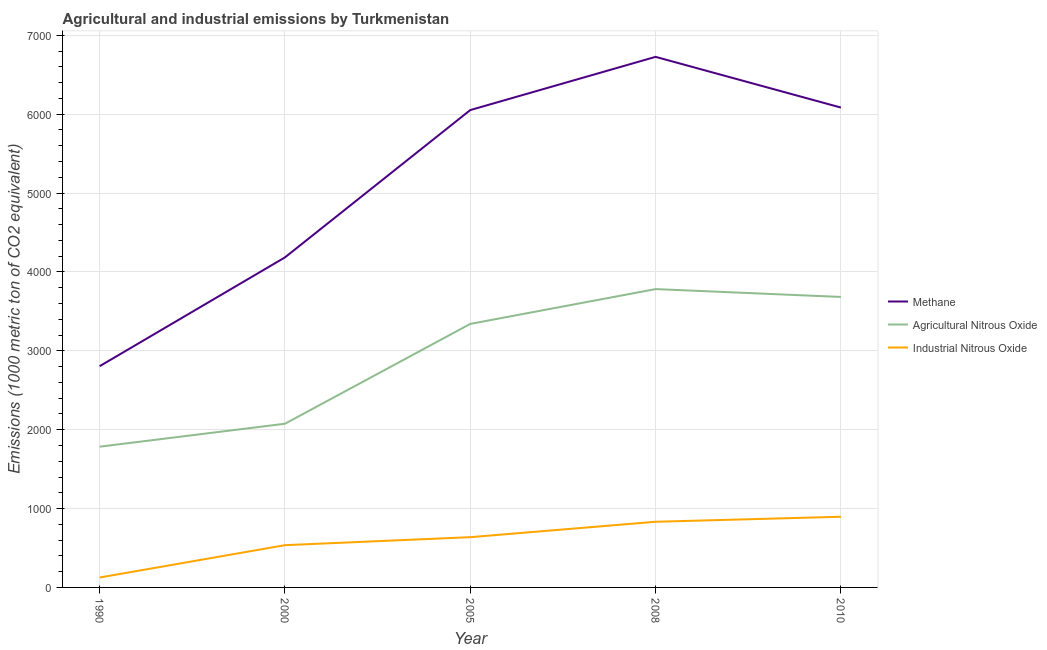How many different coloured lines are there?
Your response must be concise. 3. Does the line corresponding to amount of agricultural nitrous oxide emissions intersect with the line corresponding to amount of methane emissions?
Keep it short and to the point. No. Is the number of lines equal to the number of legend labels?
Your answer should be very brief. Yes. What is the amount of agricultural nitrous oxide emissions in 2000?
Offer a terse response. 2075.3. Across all years, what is the maximum amount of methane emissions?
Offer a terse response. 6726.9. Across all years, what is the minimum amount of industrial nitrous oxide emissions?
Provide a succinct answer. 125.6. What is the total amount of agricultural nitrous oxide emissions in the graph?
Provide a succinct answer. 1.47e+04. What is the difference between the amount of industrial nitrous oxide emissions in 2005 and that in 2008?
Make the answer very short. -195.3. What is the difference between the amount of industrial nitrous oxide emissions in 2008 and the amount of agricultural nitrous oxide emissions in 2000?
Provide a succinct answer. -1242.8. What is the average amount of methane emissions per year?
Offer a very short reply. 5170.44. In the year 2005, what is the difference between the amount of agricultural nitrous oxide emissions and amount of industrial nitrous oxide emissions?
Offer a very short reply. 2704.1. What is the ratio of the amount of methane emissions in 2005 to that in 2008?
Ensure brevity in your answer.  0.9. Is the amount of agricultural nitrous oxide emissions in 2000 less than that in 2010?
Provide a succinct answer. Yes. Is the difference between the amount of methane emissions in 2000 and 2008 greater than the difference between the amount of industrial nitrous oxide emissions in 2000 and 2008?
Offer a very short reply. No. What is the difference between the highest and the second highest amount of agricultural nitrous oxide emissions?
Keep it short and to the point. 99.5. What is the difference between the highest and the lowest amount of industrial nitrous oxide emissions?
Your answer should be very brief. 770.5. In how many years, is the amount of industrial nitrous oxide emissions greater than the average amount of industrial nitrous oxide emissions taken over all years?
Provide a short and direct response. 3. Is the sum of the amount of methane emissions in 2008 and 2010 greater than the maximum amount of industrial nitrous oxide emissions across all years?
Provide a succinct answer. Yes. Is it the case that in every year, the sum of the amount of methane emissions and amount of agricultural nitrous oxide emissions is greater than the amount of industrial nitrous oxide emissions?
Your answer should be very brief. Yes. Is the amount of agricultural nitrous oxide emissions strictly greater than the amount of methane emissions over the years?
Provide a short and direct response. No. How many lines are there?
Your answer should be compact. 3. How many years are there in the graph?
Offer a terse response. 5. What is the difference between two consecutive major ticks on the Y-axis?
Your answer should be compact. 1000. Where does the legend appear in the graph?
Provide a succinct answer. Center right. How many legend labels are there?
Make the answer very short. 3. How are the legend labels stacked?
Your response must be concise. Vertical. What is the title of the graph?
Provide a succinct answer. Agricultural and industrial emissions by Turkmenistan. Does "Food" appear as one of the legend labels in the graph?
Offer a terse response. No. What is the label or title of the Y-axis?
Your response must be concise. Emissions (1000 metric ton of CO2 equivalent). What is the Emissions (1000 metric ton of CO2 equivalent) of Methane in 1990?
Keep it short and to the point. 2804.7. What is the Emissions (1000 metric ton of CO2 equivalent) in Agricultural Nitrous Oxide in 1990?
Keep it short and to the point. 1784.5. What is the Emissions (1000 metric ton of CO2 equivalent) in Industrial Nitrous Oxide in 1990?
Your answer should be very brief. 125.6. What is the Emissions (1000 metric ton of CO2 equivalent) in Methane in 2000?
Offer a very short reply. 4184.3. What is the Emissions (1000 metric ton of CO2 equivalent) in Agricultural Nitrous Oxide in 2000?
Your answer should be very brief. 2075.3. What is the Emissions (1000 metric ton of CO2 equivalent) in Industrial Nitrous Oxide in 2000?
Provide a short and direct response. 535.7. What is the Emissions (1000 metric ton of CO2 equivalent) of Methane in 2005?
Your response must be concise. 6052.3. What is the Emissions (1000 metric ton of CO2 equivalent) in Agricultural Nitrous Oxide in 2005?
Offer a terse response. 3341.3. What is the Emissions (1000 metric ton of CO2 equivalent) of Industrial Nitrous Oxide in 2005?
Ensure brevity in your answer.  637.2. What is the Emissions (1000 metric ton of CO2 equivalent) of Methane in 2008?
Ensure brevity in your answer.  6726.9. What is the Emissions (1000 metric ton of CO2 equivalent) in Agricultural Nitrous Oxide in 2008?
Offer a very short reply. 3782.4. What is the Emissions (1000 metric ton of CO2 equivalent) of Industrial Nitrous Oxide in 2008?
Keep it short and to the point. 832.5. What is the Emissions (1000 metric ton of CO2 equivalent) in Methane in 2010?
Give a very brief answer. 6084. What is the Emissions (1000 metric ton of CO2 equivalent) of Agricultural Nitrous Oxide in 2010?
Offer a terse response. 3682.9. What is the Emissions (1000 metric ton of CO2 equivalent) of Industrial Nitrous Oxide in 2010?
Your answer should be very brief. 896.1. Across all years, what is the maximum Emissions (1000 metric ton of CO2 equivalent) in Methane?
Make the answer very short. 6726.9. Across all years, what is the maximum Emissions (1000 metric ton of CO2 equivalent) of Agricultural Nitrous Oxide?
Provide a short and direct response. 3782.4. Across all years, what is the maximum Emissions (1000 metric ton of CO2 equivalent) of Industrial Nitrous Oxide?
Offer a very short reply. 896.1. Across all years, what is the minimum Emissions (1000 metric ton of CO2 equivalent) in Methane?
Ensure brevity in your answer.  2804.7. Across all years, what is the minimum Emissions (1000 metric ton of CO2 equivalent) in Agricultural Nitrous Oxide?
Make the answer very short. 1784.5. Across all years, what is the minimum Emissions (1000 metric ton of CO2 equivalent) in Industrial Nitrous Oxide?
Your answer should be very brief. 125.6. What is the total Emissions (1000 metric ton of CO2 equivalent) of Methane in the graph?
Keep it short and to the point. 2.59e+04. What is the total Emissions (1000 metric ton of CO2 equivalent) of Agricultural Nitrous Oxide in the graph?
Offer a terse response. 1.47e+04. What is the total Emissions (1000 metric ton of CO2 equivalent) in Industrial Nitrous Oxide in the graph?
Your answer should be compact. 3027.1. What is the difference between the Emissions (1000 metric ton of CO2 equivalent) in Methane in 1990 and that in 2000?
Make the answer very short. -1379.6. What is the difference between the Emissions (1000 metric ton of CO2 equivalent) of Agricultural Nitrous Oxide in 1990 and that in 2000?
Your answer should be compact. -290.8. What is the difference between the Emissions (1000 metric ton of CO2 equivalent) in Industrial Nitrous Oxide in 1990 and that in 2000?
Give a very brief answer. -410.1. What is the difference between the Emissions (1000 metric ton of CO2 equivalent) in Methane in 1990 and that in 2005?
Make the answer very short. -3247.6. What is the difference between the Emissions (1000 metric ton of CO2 equivalent) in Agricultural Nitrous Oxide in 1990 and that in 2005?
Your response must be concise. -1556.8. What is the difference between the Emissions (1000 metric ton of CO2 equivalent) in Industrial Nitrous Oxide in 1990 and that in 2005?
Your response must be concise. -511.6. What is the difference between the Emissions (1000 metric ton of CO2 equivalent) of Methane in 1990 and that in 2008?
Provide a short and direct response. -3922.2. What is the difference between the Emissions (1000 metric ton of CO2 equivalent) of Agricultural Nitrous Oxide in 1990 and that in 2008?
Your answer should be very brief. -1997.9. What is the difference between the Emissions (1000 metric ton of CO2 equivalent) of Industrial Nitrous Oxide in 1990 and that in 2008?
Offer a terse response. -706.9. What is the difference between the Emissions (1000 metric ton of CO2 equivalent) in Methane in 1990 and that in 2010?
Ensure brevity in your answer.  -3279.3. What is the difference between the Emissions (1000 metric ton of CO2 equivalent) in Agricultural Nitrous Oxide in 1990 and that in 2010?
Give a very brief answer. -1898.4. What is the difference between the Emissions (1000 metric ton of CO2 equivalent) in Industrial Nitrous Oxide in 1990 and that in 2010?
Give a very brief answer. -770.5. What is the difference between the Emissions (1000 metric ton of CO2 equivalent) of Methane in 2000 and that in 2005?
Offer a terse response. -1868. What is the difference between the Emissions (1000 metric ton of CO2 equivalent) in Agricultural Nitrous Oxide in 2000 and that in 2005?
Keep it short and to the point. -1266. What is the difference between the Emissions (1000 metric ton of CO2 equivalent) in Industrial Nitrous Oxide in 2000 and that in 2005?
Provide a succinct answer. -101.5. What is the difference between the Emissions (1000 metric ton of CO2 equivalent) in Methane in 2000 and that in 2008?
Your answer should be very brief. -2542.6. What is the difference between the Emissions (1000 metric ton of CO2 equivalent) of Agricultural Nitrous Oxide in 2000 and that in 2008?
Your response must be concise. -1707.1. What is the difference between the Emissions (1000 metric ton of CO2 equivalent) of Industrial Nitrous Oxide in 2000 and that in 2008?
Provide a short and direct response. -296.8. What is the difference between the Emissions (1000 metric ton of CO2 equivalent) in Methane in 2000 and that in 2010?
Your answer should be compact. -1899.7. What is the difference between the Emissions (1000 metric ton of CO2 equivalent) of Agricultural Nitrous Oxide in 2000 and that in 2010?
Your answer should be compact. -1607.6. What is the difference between the Emissions (1000 metric ton of CO2 equivalent) in Industrial Nitrous Oxide in 2000 and that in 2010?
Offer a very short reply. -360.4. What is the difference between the Emissions (1000 metric ton of CO2 equivalent) in Methane in 2005 and that in 2008?
Provide a succinct answer. -674.6. What is the difference between the Emissions (1000 metric ton of CO2 equivalent) in Agricultural Nitrous Oxide in 2005 and that in 2008?
Your response must be concise. -441.1. What is the difference between the Emissions (1000 metric ton of CO2 equivalent) in Industrial Nitrous Oxide in 2005 and that in 2008?
Provide a short and direct response. -195.3. What is the difference between the Emissions (1000 metric ton of CO2 equivalent) in Methane in 2005 and that in 2010?
Offer a terse response. -31.7. What is the difference between the Emissions (1000 metric ton of CO2 equivalent) of Agricultural Nitrous Oxide in 2005 and that in 2010?
Ensure brevity in your answer.  -341.6. What is the difference between the Emissions (1000 metric ton of CO2 equivalent) in Industrial Nitrous Oxide in 2005 and that in 2010?
Provide a short and direct response. -258.9. What is the difference between the Emissions (1000 metric ton of CO2 equivalent) in Methane in 2008 and that in 2010?
Offer a terse response. 642.9. What is the difference between the Emissions (1000 metric ton of CO2 equivalent) of Agricultural Nitrous Oxide in 2008 and that in 2010?
Give a very brief answer. 99.5. What is the difference between the Emissions (1000 metric ton of CO2 equivalent) of Industrial Nitrous Oxide in 2008 and that in 2010?
Give a very brief answer. -63.6. What is the difference between the Emissions (1000 metric ton of CO2 equivalent) in Methane in 1990 and the Emissions (1000 metric ton of CO2 equivalent) in Agricultural Nitrous Oxide in 2000?
Offer a very short reply. 729.4. What is the difference between the Emissions (1000 metric ton of CO2 equivalent) in Methane in 1990 and the Emissions (1000 metric ton of CO2 equivalent) in Industrial Nitrous Oxide in 2000?
Your answer should be compact. 2269. What is the difference between the Emissions (1000 metric ton of CO2 equivalent) in Agricultural Nitrous Oxide in 1990 and the Emissions (1000 metric ton of CO2 equivalent) in Industrial Nitrous Oxide in 2000?
Your answer should be very brief. 1248.8. What is the difference between the Emissions (1000 metric ton of CO2 equivalent) of Methane in 1990 and the Emissions (1000 metric ton of CO2 equivalent) of Agricultural Nitrous Oxide in 2005?
Your answer should be very brief. -536.6. What is the difference between the Emissions (1000 metric ton of CO2 equivalent) of Methane in 1990 and the Emissions (1000 metric ton of CO2 equivalent) of Industrial Nitrous Oxide in 2005?
Provide a succinct answer. 2167.5. What is the difference between the Emissions (1000 metric ton of CO2 equivalent) of Agricultural Nitrous Oxide in 1990 and the Emissions (1000 metric ton of CO2 equivalent) of Industrial Nitrous Oxide in 2005?
Keep it short and to the point. 1147.3. What is the difference between the Emissions (1000 metric ton of CO2 equivalent) of Methane in 1990 and the Emissions (1000 metric ton of CO2 equivalent) of Agricultural Nitrous Oxide in 2008?
Give a very brief answer. -977.7. What is the difference between the Emissions (1000 metric ton of CO2 equivalent) of Methane in 1990 and the Emissions (1000 metric ton of CO2 equivalent) of Industrial Nitrous Oxide in 2008?
Provide a short and direct response. 1972.2. What is the difference between the Emissions (1000 metric ton of CO2 equivalent) of Agricultural Nitrous Oxide in 1990 and the Emissions (1000 metric ton of CO2 equivalent) of Industrial Nitrous Oxide in 2008?
Keep it short and to the point. 952. What is the difference between the Emissions (1000 metric ton of CO2 equivalent) of Methane in 1990 and the Emissions (1000 metric ton of CO2 equivalent) of Agricultural Nitrous Oxide in 2010?
Give a very brief answer. -878.2. What is the difference between the Emissions (1000 metric ton of CO2 equivalent) of Methane in 1990 and the Emissions (1000 metric ton of CO2 equivalent) of Industrial Nitrous Oxide in 2010?
Your answer should be very brief. 1908.6. What is the difference between the Emissions (1000 metric ton of CO2 equivalent) in Agricultural Nitrous Oxide in 1990 and the Emissions (1000 metric ton of CO2 equivalent) in Industrial Nitrous Oxide in 2010?
Your answer should be very brief. 888.4. What is the difference between the Emissions (1000 metric ton of CO2 equivalent) of Methane in 2000 and the Emissions (1000 metric ton of CO2 equivalent) of Agricultural Nitrous Oxide in 2005?
Keep it short and to the point. 843. What is the difference between the Emissions (1000 metric ton of CO2 equivalent) of Methane in 2000 and the Emissions (1000 metric ton of CO2 equivalent) of Industrial Nitrous Oxide in 2005?
Your response must be concise. 3547.1. What is the difference between the Emissions (1000 metric ton of CO2 equivalent) in Agricultural Nitrous Oxide in 2000 and the Emissions (1000 metric ton of CO2 equivalent) in Industrial Nitrous Oxide in 2005?
Offer a terse response. 1438.1. What is the difference between the Emissions (1000 metric ton of CO2 equivalent) in Methane in 2000 and the Emissions (1000 metric ton of CO2 equivalent) in Agricultural Nitrous Oxide in 2008?
Offer a terse response. 401.9. What is the difference between the Emissions (1000 metric ton of CO2 equivalent) of Methane in 2000 and the Emissions (1000 metric ton of CO2 equivalent) of Industrial Nitrous Oxide in 2008?
Keep it short and to the point. 3351.8. What is the difference between the Emissions (1000 metric ton of CO2 equivalent) in Agricultural Nitrous Oxide in 2000 and the Emissions (1000 metric ton of CO2 equivalent) in Industrial Nitrous Oxide in 2008?
Make the answer very short. 1242.8. What is the difference between the Emissions (1000 metric ton of CO2 equivalent) in Methane in 2000 and the Emissions (1000 metric ton of CO2 equivalent) in Agricultural Nitrous Oxide in 2010?
Your answer should be compact. 501.4. What is the difference between the Emissions (1000 metric ton of CO2 equivalent) in Methane in 2000 and the Emissions (1000 metric ton of CO2 equivalent) in Industrial Nitrous Oxide in 2010?
Offer a terse response. 3288.2. What is the difference between the Emissions (1000 metric ton of CO2 equivalent) of Agricultural Nitrous Oxide in 2000 and the Emissions (1000 metric ton of CO2 equivalent) of Industrial Nitrous Oxide in 2010?
Make the answer very short. 1179.2. What is the difference between the Emissions (1000 metric ton of CO2 equivalent) in Methane in 2005 and the Emissions (1000 metric ton of CO2 equivalent) in Agricultural Nitrous Oxide in 2008?
Provide a short and direct response. 2269.9. What is the difference between the Emissions (1000 metric ton of CO2 equivalent) in Methane in 2005 and the Emissions (1000 metric ton of CO2 equivalent) in Industrial Nitrous Oxide in 2008?
Provide a short and direct response. 5219.8. What is the difference between the Emissions (1000 metric ton of CO2 equivalent) of Agricultural Nitrous Oxide in 2005 and the Emissions (1000 metric ton of CO2 equivalent) of Industrial Nitrous Oxide in 2008?
Offer a terse response. 2508.8. What is the difference between the Emissions (1000 metric ton of CO2 equivalent) of Methane in 2005 and the Emissions (1000 metric ton of CO2 equivalent) of Agricultural Nitrous Oxide in 2010?
Ensure brevity in your answer.  2369.4. What is the difference between the Emissions (1000 metric ton of CO2 equivalent) in Methane in 2005 and the Emissions (1000 metric ton of CO2 equivalent) in Industrial Nitrous Oxide in 2010?
Offer a very short reply. 5156.2. What is the difference between the Emissions (1000 metric ton of CO2 equivalent) of Agricultural Nitrous Oxide in 2005 and the Emissions (1000 metric ton of CO2 equivalent) of Industrial Nitrous Oxide in 2010?
Your answer should be compact. 2445.2. What is the difference between the Emissions (1000 metric ton of CO2 equivalent) of Methane in 2008 and the Emissions (1000 metric ton of CO2 equivalent) of Agricultural Nitrous Oxide in 2010?
Make the answer very short. 3044. What is the difference between the Emissions (1000 metric ton of CO2 equivalent) of Methane in 2008 and the Emissions (1000 metric ton of CO2 equivalent) of Industrial Nitrous Oxide in 2010?
Provide a succinct answer. 5830.8. What is the difference between the Emissions (1000 metric ton of CO2 equivalent) in Agricultural Nitrous Oxide in 2008 and the Emissions (1000 metric ton of CO2 equivalent) in Industrial Nitrous Oxide in 2010?
Offer a very short reply. 2886.3. What is the average Emissions (1000 metric ton of CO2 equivalent) in Methane per year?
Your response must be concise. 5170.44. What is the average Emissions (1000 metric ton of CO2 equivalent) of Agricultural Nitrous Oxide per year?
Your answer should be compact. 2933.28. What is the average Emissions (1000 metric ton of CO2 equivalent) in Industrial Nitrous Oxide per year?
Make the answer very short. 605.42. In the year 1990, what is the difference between the Emissions (1000 metric ton of CO2 equivalent) in Methane and Emissions (1000 metric ton of CO2 equivalent) in Agricultural Nitrous Oxide?
Your response must be concise. 1020.2. In the year 1990, what is the difference between the Emissions (1000 metric ton of CO2 equivalent) of Methane and Emissions (1000 metric ton of CO2 equivalent) of Industrial Nitrous Oxide?
Provide a succinct answer. 2679.1. In the year 1990, what is the difference between the Emissions (1000 metric ton of CO2 equivalent) of Agricultural Nitrous Oxide and Emissions (1000 metric ton of CO2 equivalent) of Industrial Nitrous Oxide?
Offer a very short reply. 1658.9. In the year 2000, what is the difference between the Emissions (1000 metric ton of CO2 equivalent) in Methane and Emissions (1000 metric ton of CO2 equivalent) in Agricultural Nitrous Oxide?
Keep it short and to the point. 2109. In the year 2000, what is the difference between the Emissions (1000 metric ton of CO2 equivalent) of Methane and Emissions (1000 metric ton of CO2 equivalent) of Industrial Nitrous Oxide?
Ensure brevity in your answer.  3648.6. In the year 2000, what is the difference between the Emissions (1000 metric ton of CO2 equivalent) in Agricultural Nitrous Oxide and Emissions (1000 metric ton of CO2 equivalent) in Industrial Nitrous Oxide?
Your answer should be compact. 1539.6. In the year 2005, what is the difference between the Emissions (1000 metric ton of CO2 equivalent) in Methane and Emissions (1000 metric ton of CO2 equivalent) in Agricultural Nitrous Oxide?
Your response must be concise. 2711. In the year 2005, what is the difference between the Emissions (1000 metric ton of CO2 equivalent) of Methane and Emissions (1000 metric ton of CO2 equivalent) of Industrial Nitrous Oxide?
Your answer should be compact. 5415.1. In the year 2005, what is the difference between the Emissions (1000 metric ton of CO2 equivalent) of Agricultural Nitrous Oxide and Emissions (1000 metric ton of CO2 equivalent) of Industrial Nitrous Oxide?
Keep it short and to the point. 2704.1. In the year 2008, what is the difference between the Emissions (1000 metric ton of CO2 equivalent) of Methane and Emissions (1000 metric ton of CO2 equivalent) of Agricultural Nitrous Oxide?
Keep it short and to the point. 2944.5. In the year 2008, what is the difference between the Emissions (1000 metric ton of CO2 equivalent) of Methane and Emissions (1000 metric ton of CO2 equivalent) of Industrial Nitrous Oxide?
Provide a succinct answer. 5894.4. In the year 2008, what is the difference between the Emissions (1000 metric ton of CO2 equivalent) of Agricultural Nitrous Oxide and Emissions (1000 metric ton of CO2 equivalent) of Industrial Nitrous Oxide?
Offer a very short reply. 2949.9. In the year 2010, what is the difference between the Emissions (1000 metric ton of CO2 equivalent) of Methane and Emissions (1000 metric ton of CO2 equivalent) of Agricultural Nitrous Oxide?
Offer a very short reply. 2401.1. In the year 2010, what is the difference between the Emissions (1000 metric ton of CO2 equivalent) of Methane and Emissions (1000 metric ton of CO2 equivalent) of Industrial Nitrous Oxide?
Keep it short and to the point. 5187.9. In the year 2010, what is the difference between the Emissions (1000 metric ton of CO2 equivalent) of Agricultural Nitrous Oxide and Emissions (1000 metric ton of CO2 equivalent) of Industrial Nitrous Oxide?
Provide a succinct answer. 2786.8. What is the ratio of the Emissions (1000 metric ton of CO2 equivalent) in Methane in 1990 to that in 2000?
Keep it short and to the point. 0.67. What is the ratio of the Emissions (1000 metric ton of CO2 equivalent) of Agricultural Nitrous Oxide in 1990 to that in 2000?
Make the answer very short. 0.86. What is the ratio of the Emissions (1000 metric ton of CO2 equivalent) in Industrial Nitrous Oxide in 1990 to that in 2000?
Your answer should be compact. 0.23. What is the ratio of the Emissions (1000 metric ton of CO2 equivalent) of Methane in 1990 to that in 2005?
Make the answer very short. 0.46. What is the ratio of the Emissions (1000 metric ton of CO2 equivalent) of Agricultural Nitrous Oxide in 1990 to that in 2005?
Your response must be concise. 0.53. What is the ratio of the Emissions (1000 metric ton of CO2 equivalent) of Industrial Nitrous Oxide in 1990 to that in 2005?
Your answer should be very brief. 0.2. What is the ratio of the Emissions (1000 metric ton of CO2 equivalent) in Methane in 1990 to that in 2008?
Your answer should be very brief. 0.42. What is the ratio of the Emissions (1000 metric ton of CO2 equivalent) of Agricultural Nitrous Oxide in 1990 to that in 2008?
Offer a very short reply. 0.47. What is the ratio of the Emissions (1000 metric ton of CO2 equivalent) of Industrial Nitrous Oxide in 1990 to that in 2008?
Give a very brief answer. 0.15. What is the ratio of the Emissions (1000 metric ton of CO2 equivalent) of Methane in 1990 to that in 2010?
Give a very brief answer. 0.46. What is the ratio of the Emissions (1000 metric ton of CO2 equivalent) of Agricultural Nitrous Oxide in 1990 to that in 2010?
Provide a short and direct response. 0.48. What is the ratio of the Emissions (1000 metric ton of CO2 equivalent) of Industrial Nitrous Oxide in 1990 to that in 2010?
Offer a very short reply. 0.14. What is the ratio of the Emissions (1000 metric ton of CO2 equivalent) in Methane in 2000 to that in 2005?
Ensure brevity in your answer.  0.69. What is the ratio of the Emissions (1000 metric ton of CO2 equivalent) in Agricultural Nitrous Oxide in 2000 to that in 2005?
Ensure brevity in your answer.  0.62. What is the ratio of the Emissions (1000 metric ton of CO2 equivalent) of Industrial Nitrous Oxide in 2000 to that in 2005?
Offer a terse response. 0.84. What is the ratio of the Emissions (1000 metric ton of CO2 equivalent) in Methane in 2000 to that in 2008?
Offer a very short reply. 0.62. What is the ratio of the Emissions (1000 metric ton of CO2 equivalent) in Agricultural Nitrous Oxide in 2000 to that in 2008?
Your answer should be very brief. 0.55. What is the ratio of the Emissions (1000 metric ton of CO2 equivalent) of Industrial Nitrous Oxide in 2000 to that in 2008?
Your answer should be very brief. 0.64. What is the ratio of the Emissions (1000 metric ton of CO2 equivalent) of Methane in 2000 to that in 2010?
Your answer should be very brief. 0.69. What is the ratio of the Emissions (1000 metric ton of CO2 equivalent) of Agricultural Nitrous Oxide in 2000 to that in 2010?
Provide a succinct answer. 0.56. What is the ratio of the Emissions (1000 metric ton of CO2 equivalent) of Industrial Nitrous Oxide in 2000 to that in 2010?
Keep it short and to the point. 0.6. What is the ratio of the Emissions (1000 metric ton of CO2 equivalent) of Methane in 2005 to that in 2008?
Make the answer very short. 0.9. What is the ratio of the Emissions (1000 metric ton of CO2 equivalent) in Agricultural Nitrous Oxide in 2005 to that in 2008?
Provide a succinct answer. 0.88. What is the ratio of the Emissions (1000 metric ton of CO2 equivalent) of Industrial Nitrous Oxide in 2005 to that in 2008?
Provide a succinct answer. 0.77. What is the ratio of the Emissions (1000 metric ton of CO2 equivalent) in Methane in 2005 to that in 2010?
Keep it short and to the point. 0.99. What is the ratio of the Emissions (1000 metric ton of CO2 equivalent) of Agricultural Nitrous Oxide in 2005 to that in 2010?
Offer a terse response. 0.91. What is the ratio of the Emissions (1000 metric ton of CO2 equivalent) of Industrial Nitrous Oxide in 2005 to that in 2010?
Make the answer very short. 0.71. What is the ratio of the Emissions (1000 metric ton of CO2 equivalent) in Methane in 2008 to that in 2010?
Keep it short and to the point. 1.11. What is the ratio of the Emissions (1000 metric ton of CO2 equivalent) of Agricultural Nitrous Oxide in 2008 to that in 2010?
Offer a very short reply. 1.03. What is the ratio of the Emissions (1000 metric ton of CO2 equivalent) of Industrial Nitrous Oxide in 2008 to that in 2010?
Keep it short and to the point. 0.93. What is the difference between the highest and the second highest Emissions (1000 metric ton of CO2 equivalent) of Methane?
Your response must be concise. 642.9. What is the difference between the highest and the second highest Emissions (1000 metric ton of CO2 equivalent) of Agricultural Nitrous Oxide?
Offer a very short reply. 99.5. What is the difference between the highest and the second highest Emissions (1000 metric ton of CO2 equivalent) in Industrial Nitrous Oxide?
Ensure brevity in your answer.  63.6. What is the difference between the highest and the lowest Emissions (1000 metric ton of CO2 equivalent) in Methane?
Your response must be concise. 3922.2. What is the difference between the highest and the lowest Emissions (1000 metric ton of CO2 equivalent) of Agricultural Nitrous Oxide?
Provide a succinct answer. 1997.9. What is the difference between the highest and the lowest Emissions (1000 metric ton of CO2 equivalent) in Industrial Nitrous Oxide?
Your answer should be very brief. 770.5. 